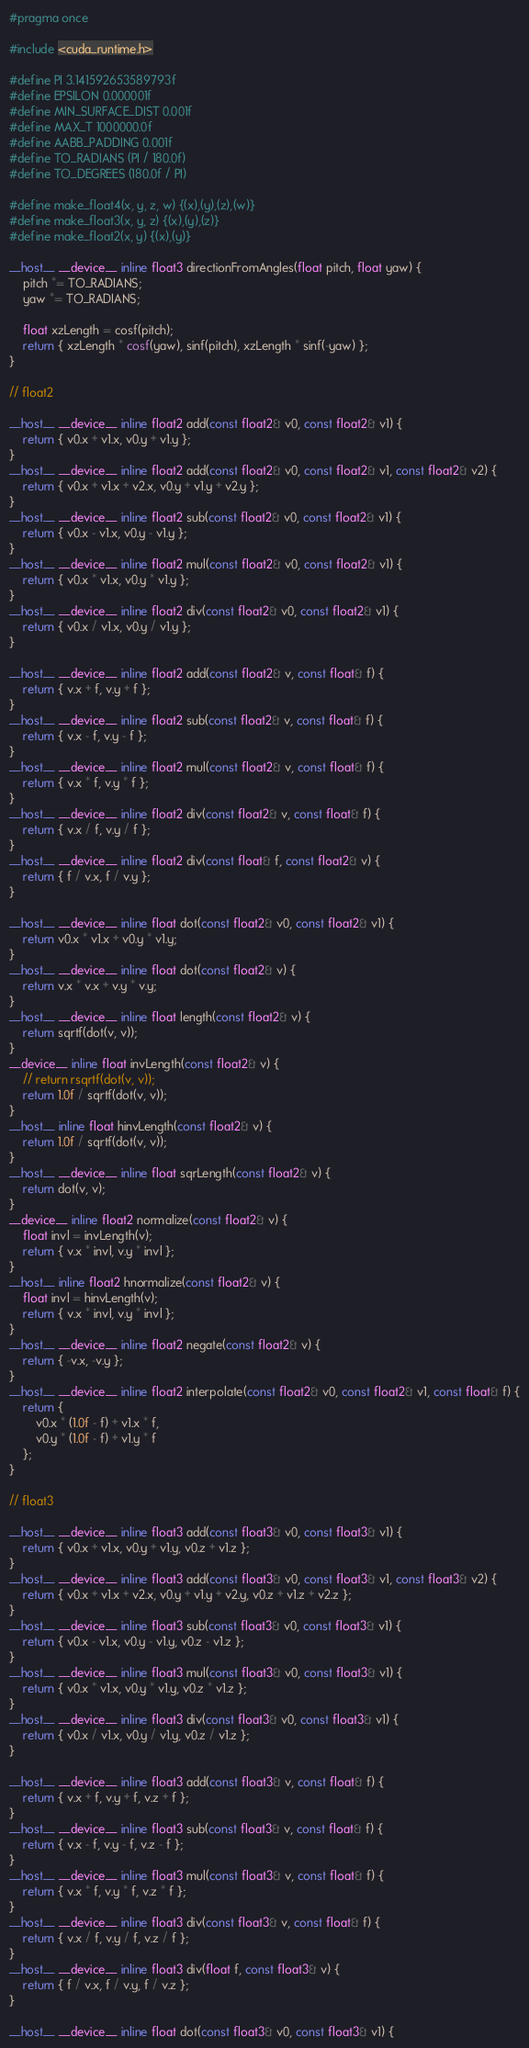<code> <loc_0><loc_0><loc_500><loc_500><_Cuda_>#pragma once

#include <cuda_runtime.h>

#define PI 3.141592653589793f
#define EPSILON 0.000001f
#define MIN_SURFACE_DIST 0.001f
#define MAX_T 1000000.0f
#define AABB_PADDING 0.001f
#define TO_RADIANS (PI / 180.0f)
#define TO_DEGREES (180.0f / PI)

#define make_float4(x, y, z, w) {(x),(y),(z),(w)}
#define make_float3(x, y, z) {(x),(y),(z)}
#define make_float2(x, y) {(x),(y)}

__host__ __device__ inline float3 directionFromAngles(float pitch, float yaw) {
	pitch *= TO_RADIANS;
	yaw *= TO_RADIANS;

	float xzLength = cosf(pitch);
	return { xzLength * cosf(yaw), sinf(pitch), xzLength * sinf(-yaw) };
}

// float2

__host__ __device__ inline float2 add(const float2& v0, const float2& v1) {
	return { v0.x + v1.x, v0.y + v1.y };
}
__host__ __device__ inline float2 add(const float2& v0, const float2& v1, const float2& v2) {
	return { v0.x + v1.x + v2.x, v0.y + v1.y + v2.y };
}
__host__ __device__ inline float2 sub(const float2& v0, const float2& v1) {
	return { v0.x - v1.x, v0.y - v1.y };
}
__host__ __device__ inline float2 mul(const float2& v0, const float2& v1) {
	return { v0.x * v1.x, v0.y * v1.y };
}
__host__ __device__ inline float2 div(const float2& v0, const float2& v1) {
	return { v0.x / v1.x, v0.y / v1.y };
}

__host__ __device__ inline float2 add(const float2& v, const float& f) {
	return { v.x + f, v.y + f };
}
__host__ __device__ inline float2 sub(const float2& v, const float& f) {
	return { v.x - f, v.y - f };
}
__host__ __device__ inline float2 mul(const float2& v, const float& f) {
	return { v.x * f, v.y * f };
}
__host__ __device__ inline float2 div(const float2& v, const float& f) {
	return { v.x / f, v.y / f };
}
__host__ __device__ inline float2 div(const float& f, const float2& v) {
	return { f / v.x, f / v.y };
}

__host__ __device__ inline float dot(const float2& v0, const float2& v1) {
	return v0.x * v1.x + v0.y * v1.y;
}
__host__ __device__ inline float dot(const float2& v) {
	return v.x * v.x + v.y * v.y;
}
__host__ __device__ inline float length(const float2& v) {
	return sqrtf(dot(v, v));
}
__device__ inline float invLength(const float2& v) {
	// return rsqrtf(dot(v, v));
	return 1.0f / sqrtf(dot(v, v));
}
__host__ inline float hinvLength(const float2& v) {
	return 1.0f / sqrtf(dot(v, v));
}
__host__ __device__ inline float sqrLength(const float2& v) {
	return dot(v, v);
}
__device__ inline float2 normalize(const float2& v) {
	float invl = invLength(v);
	return { v.x * invl, v.y * invl };
}
__host__ inline float2 hnormalize(const float2& v) {
	float invl = hinvLength(v);
	return { v.x * invl, v.y * invl };
}
__host__ __device__ inline float2 negate(const float2& v) {
	return { -v.x, -v.y };
}
__host__ __device__ inline float2 interpolate(const float2& v0, const float2& v1, const float& f) {
	return {
		v0.x * (1.0f - f) + v1.x * f,
		v0.y * (1.0f - f) + v1.y * f
	};
}

// float3

__host__ __device__ inline float3 add(const float3& v0, const float3& v1) {
	return { v0.x + v1.x, v0.y + v1.y, v0.z + v1.z };
}
__host__ __device__ inline float3 add(const float3& v0, const float3& v1, const float3& v2) {
	return { v0.x + v1.x + v2.x, v0.y + v1.y + v2.y, v0.z + v1.z + v2.z };
}
__host__ __device__ inline float3 sub(const float3& v0, const float3& v1) {
	return { v0.x - v1.x, v0.y - v1.y, v0.z - v1.z };
}
__host__ __device__ inline float3 mul(const float3& v0, const float3& v1) {
	return { v0.x * v1.x, v0.y * v1.y, v0.z * v1.z };
}
__host__ __device__ inline float3 div(const float3& v0, const float3& v1) {
	return { v0.x / v1.x, v0.y / v1.y, v0.z / v1.z };
}

__host__ __device__ inline float3 add(const float3& v, const float& f) {
	return { v.x + f, v.y + f, v.z + f };
}
__host__ __device__ inline float3 sub(const float3& v, const float& f) {
	return { v.x - f, v.y - f, v.z - f };
}
__host__ __device__ inline float3 mul(const float3& v, const float& f) {
	return { v.x * f, v.y * f, v.z * f };
}
__host__ __device__ inline float3 div(const float3& v, const float& f) {
	return { v.x / f, v.y / f, v.z / f };
}
__host__ __device__ inline float3 div(float f, const float3& v) {
	return { f / v.x, f / v.y, f / v.z };
}

__host__ __device__ inline float dot(const float3& v0, const float3& v1) {</code> 